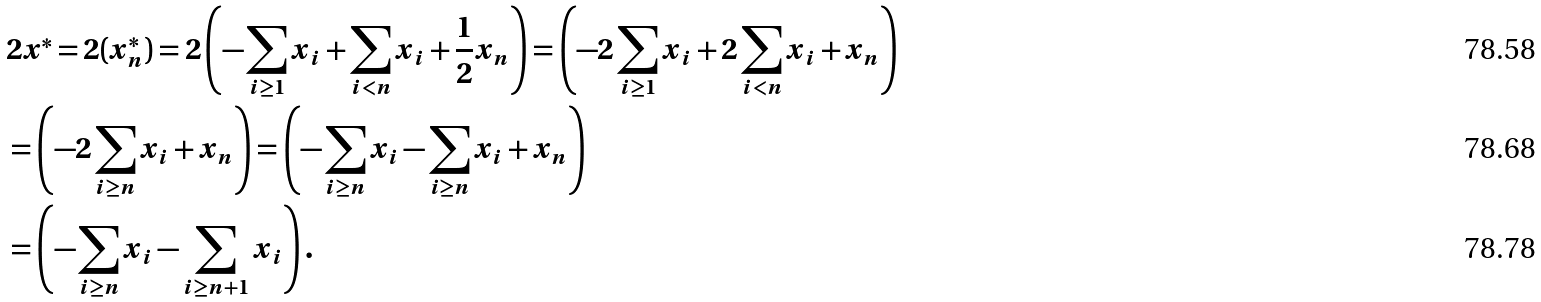Convert formula to latex. <formula><loc_0><loc_0><loc_500><loc_500>& 2 x ^ { * } = 2 ( x ^ { * } _ { n } ) = 2 \left ( - \sum _ { i \geq 1 } x _ { i } + \sum _ { i < n } x _ { i } + \frac { 1 } { 2 } x _ { n } \right ) = \left ( - 2 \sum _ { i \geq 1 } x _ { i } + 2 \sum _ { i < n } x _ { i } + x _ { n } \right ) \\ & = \left ( - 2 \sum _ { i \geq n } x _ { i } + x _ { n } \right ) = \left ( - \sum _ { i \geq n } x _ { i } - \sum _ { i \geq n } x _ { i } + x _ { n } \right ) \\ & = \left ( - \sum _ { i \geq n } x _ { i } - \sum _ { i \geq n + 1 } x _ { i } \right ) .</formula> 